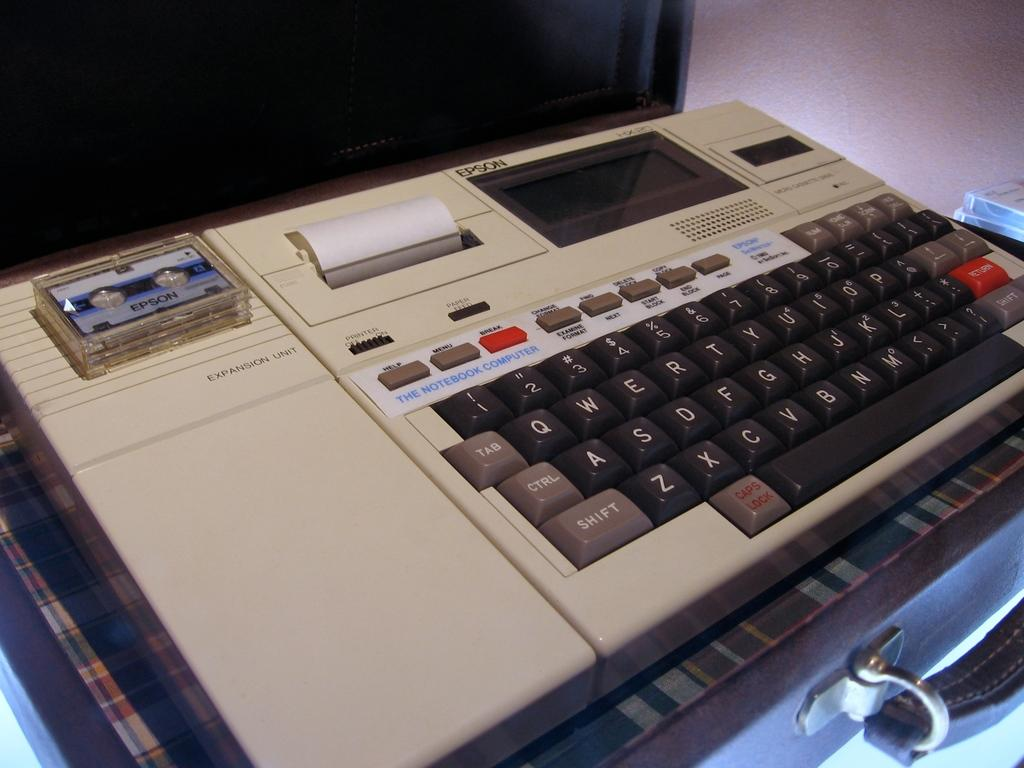<image>
Describe the image concisely. a keyboard with a label above the keys that says 'the notebook computer' 